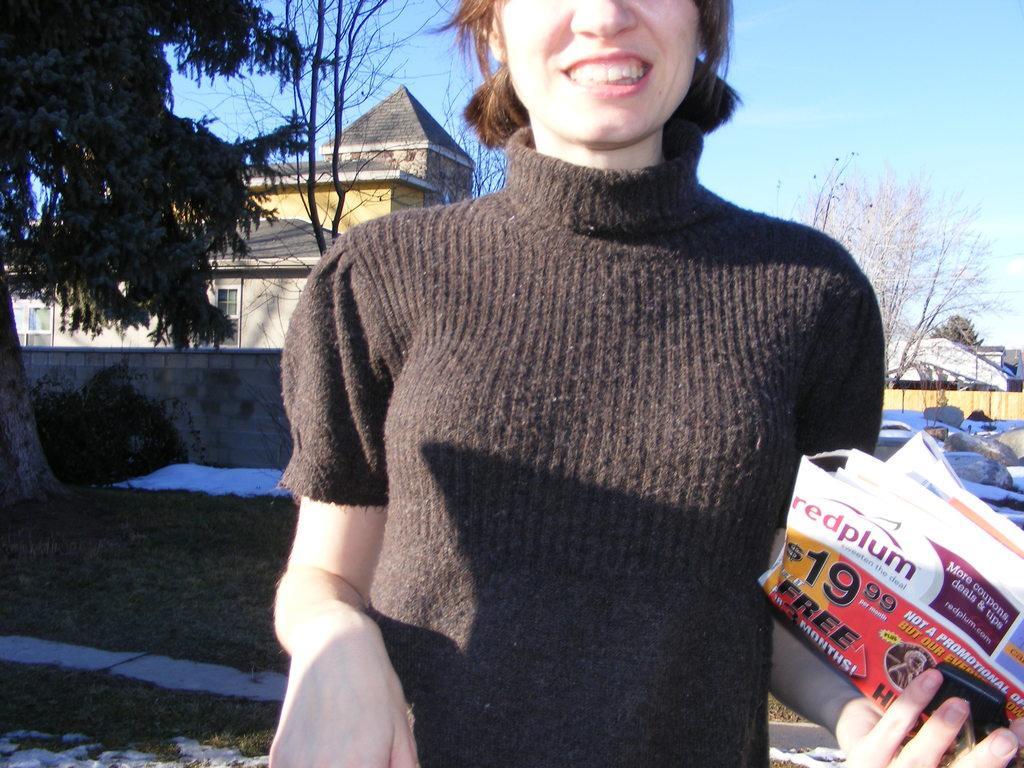In one or two sentences, can you explain what this image depicts? In this image, at the middle there is a woman, she is standing and she is holding a paper, at the left side there is grass on the ground and there is a green color tree, at the background there are some homes, at the top there is a blue color sky. 